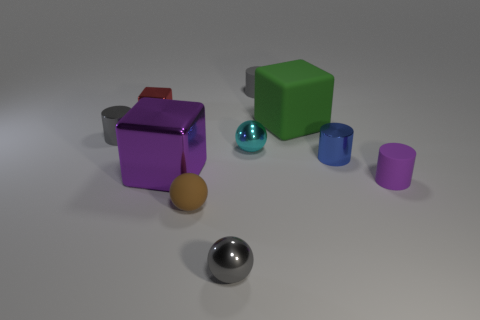Subtract all cubes. How many objects are left? 7 Add 1 rubber cylinders. How many rubber cylinders are left? 3 Add 7 yellow metallic spheres. How many yellow metallic spheres exist? 7 Subtract 0 purple spheres. How many objects are left? 10 Subtract all purple spheres. Subtract all large purple objects. How many objects are left? 9 